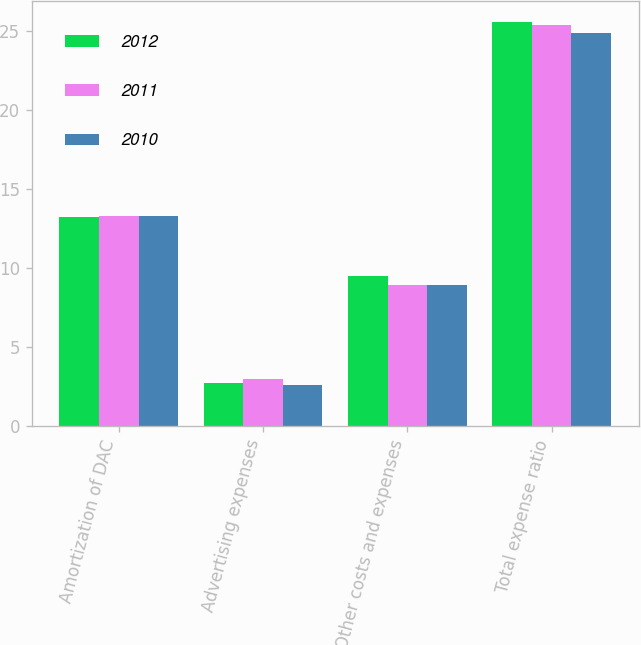Convert chart. <chart><loc_0><loc_0><loc_500><loc_500><stacked_bar_chart><ecel><fcel>Amortization of DAC<fcel>Advertising expenses<fcel>Other costs and expenses<fcel>Total expense ratio<nl><fcel>2012<fcel>13.2<fcel>2.7<fcel>9.5<fcel>25.6<nl><fcel>2011<fcel>13.3<fcel>3<fcel>8.9<fcel>25.4<nl><fcel>2010<fcel>13.3<fcel>2.6<fcel>8.9<fcel>24.9<nl></chart> 